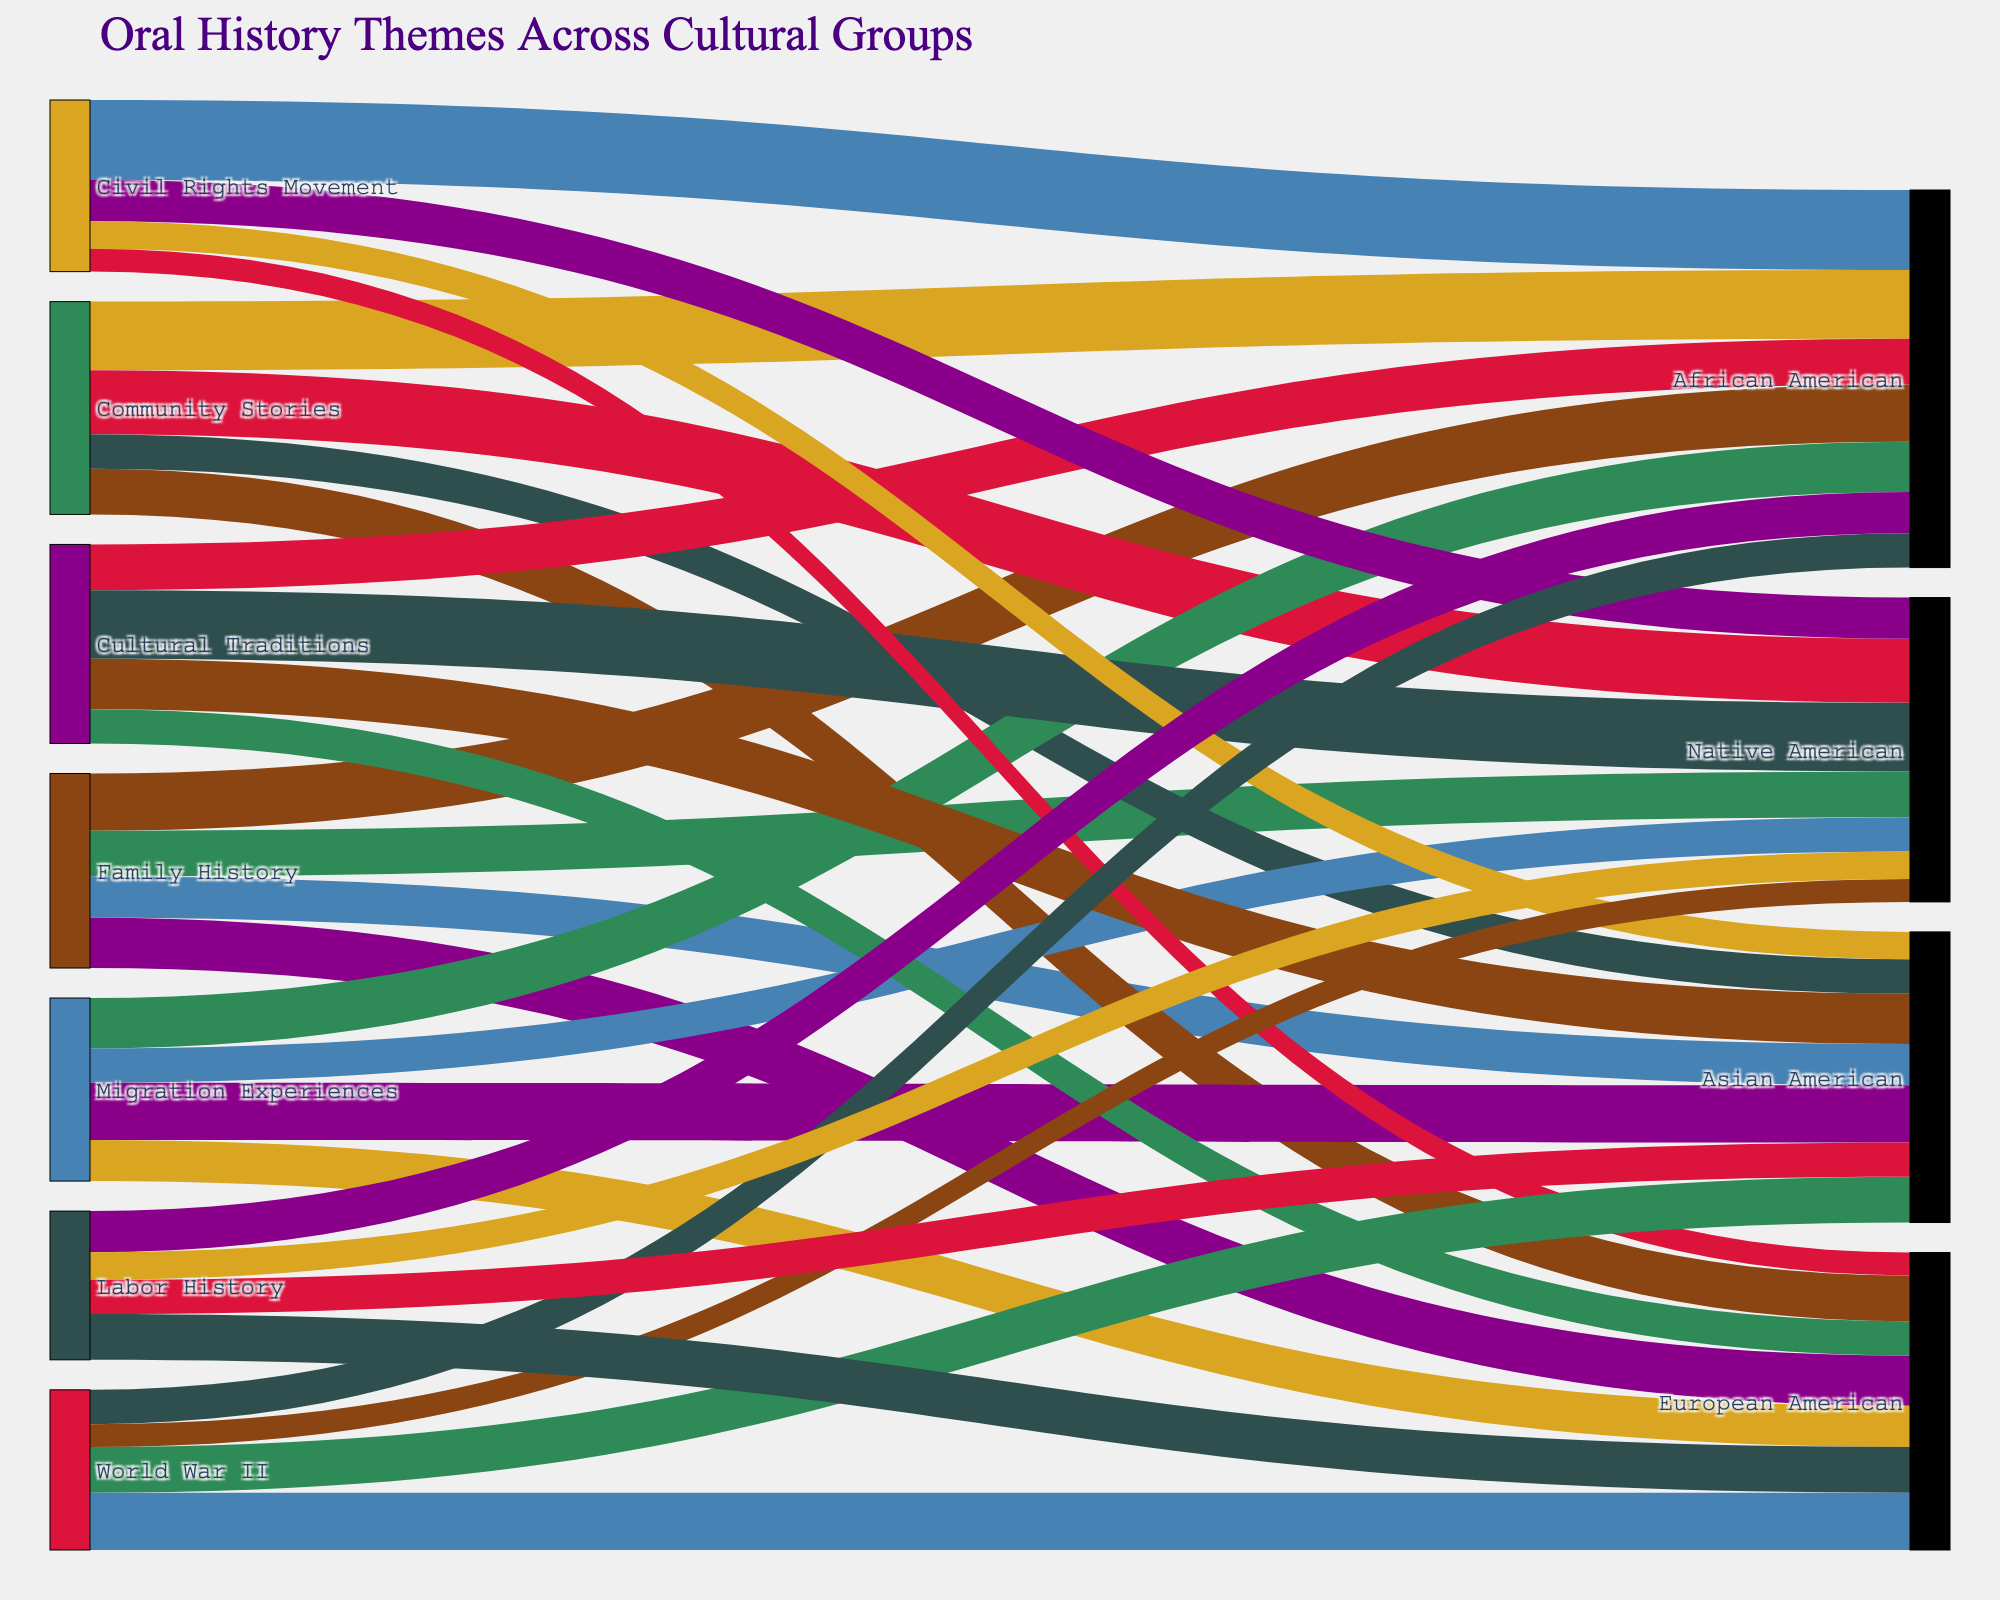what is the title of the sankey diagram? The title of the Sankey diagram is displayed at the top of the figure which reads "Oral History Themes Across Cultural Groups".
Answer: Oral History Themes Across Cultural Groups which cultural group is linked the most with the theme "Community Stories"? To determine this, observe the thickness or value of the links connected to "Community Stories". The group with the thickest link is "African American" with a value of 30.
Answer: African American how many themes are represented in the sankey diagram? Each theme is a unique source node in the diagram. By counting these nodes, we get six themes: Family History, Community Stories, Migration Experiences, Cultural Traditions, Civil Rights Movement, and World War II.
Answer: Six which theme has the smallest number of connections, and what are those connections? To identify the theme with the fewest connections, count the links per theme. "Labor History" has the fewest connections with four links to "African American" (18), "Native American" (12), "Asian American" (15), and "European American" (20).
Answer: Labor History, connections: African American, Native American, Asian American, European American what is the total value associated with the "Native American" group? Sum up all the values from the links associated with "Native American": 20 (Family History) + 28 (Community Stories) + 15 (Migration Experiences) + 30 (Cultural Traditions) + 18 (Civil Rights Movement) + 10 (World War II) + 12 (Labor History). The total is 20 + 28 + 15 + 30 + 18 + 10 + 12 = 133.
Answer: 133 compare the value of connections between "Migration Experiences" and "Community Stories" for the "Asian American" group. Which theme has a higher value, and by how much? Find the link values for "Asian American" under both themes: Migration Experiences (25) and Community Stories (15). Migration Experiences has a higher value by 25 - 15 = 10.
Answer: Migration Experiences, by 10 does the theme "Civil Rights Movement" have a higher total value of connections compared to "World War II"? Sum up the values for "Civil Rights Movement" (35 + 18 + 12 + 10 = 75) and "World War II" (15 + 10 + 20 + 25 = 70). "Civil Rights Movement" has a higher total value (75 > 70).
Answer: Yes which cultural group has the lowest value link with “Cultural Traditions”? By examining the values of the links connected to "Cultural Traditions", the "European American" group has the lowest value of 15.
Answer: European American what are the color characteristics of the nodes? The nodes are colored using a palette of distinct colors, including shades like #8B4513 (brown), #2E8B57 (green), #4682B4 (blue), #8B008B (purple), #DAA520 (gold), #DC143C (red), and #2F4F4F (gray). Each node has a unique color assigned from this palette.
Answer: Nodes are assigned distinct colors: brown, green, blue, purple, gold, red, gray 